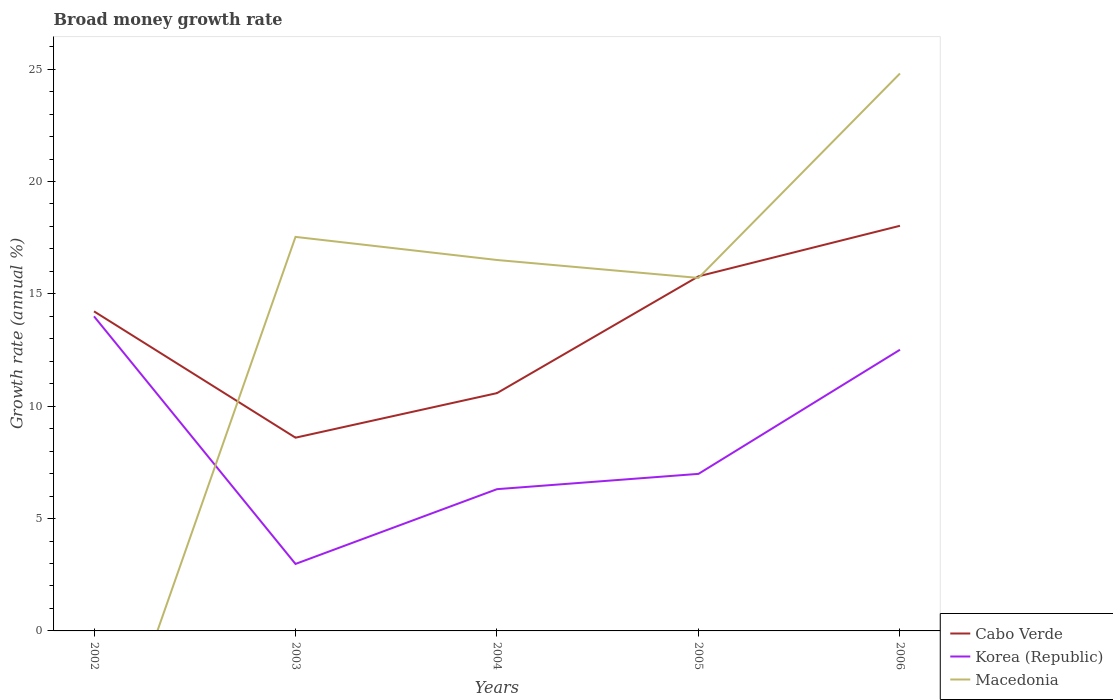How many different coloured lines are there?
Offer a terse response. 3. Does the line corresponding to Korea (Republic) intersect with the line corresponding to Macedonia?
Keep it short and to the point. Yes. What is the total growth rate in Cabo Verde in the graph?
Ensure brevity in your answer.  -2.25. What is the difference between the highest and the second highest growth rate in Cabo Verde?
Ensure brevity in your answer.  9.43. How many lines are there?
Provide a short and direct response. 3. How many years are there in the graph?
Offer a terse response. 5. What is the difference between two consecutive major ticks on the Y-axis?
Provide a succinct answer. 5. Does the graph contain any zero values?
Offer a terse response. Yes. Does the graph contain grids?
Ensure brevity in your answer.  No. Where does the legend appear in the graph?
Make the answer very short. Bottom right. What is the title of the graph?
Provide a short and direct response. Broad money growth rate. Does "Syrian Arab Republic" appear as one of the legend labels in the graph?
Give a very brief answer. No. What is the label or title of the X-axis?
Give a very brief answer. Years. What is the label or title of the Y-axis?
Keep it short and to the point. Growth rate (annual %). What is the Growth rate (annual %) of Cabo Verde in 2002?
Your response must be concise. 14.22. What is the Growth rate (annual %) in Korea (Republic) in 2002?
Give a very brief answer. 14. What is the Growth rate (annual %) in Macedonia in 2002?
Make the answer very short. 0. What is the Growth rate (annual %) in Cabo Verde in 2003?
Your response must be concise. 8.6. What is the Growth rate (annual %) of Korea (Republic) in 2003?
Keep it short and to the point. 2.98. What is the Growth rate (annual %) of Macedonia in 2003?
Your answer should be compact. 17.53. What is the Growth rate (annual %) of Cabo Verde in 2004?
Your response must be concise. 10.58. What is the Growth rate (annual %) in Korea (Republic) in 2004?
Offer a terse response. 6.31. What is the Growth rate (annual %) in Macedonia in 2004?
Ensure brevity in your answer.  16.51. What is the Growth rate (annual %) of Cabo Verde in 2005?
Offer a very short reply. 15.78. What is the Growth rate (annual %) of Korea (Republic) in 2005?
Offer a terse response. 6.99. What is the Growth rate (annual %) in Macedonia in 2005?
Keep it short and to the point. 15.71. What is the Growth rate (annual %) of Cabo Verde in 2006?
Offer a terse response. 18.03. What is the Growth rate (annual %) of Korea (Republic) in 2006?
Provide a succinct answer. 12.51. What is the Growth rate (annual %) of Macedonia in 2006?
Keep it short and to the point. 24.81. Across all years, what is the maximum Growth rate (annual %) in Cabo Verde?
Keep it short and to the point. 18.03. Across all years, what is the maximum Growth rate (annual %) of Korea (Republic)?
Provide a short and direct response. 14. Across all years, what is the maximum Growth rate (annual %) of Macedonia?
Make the answer very short. 24.81. Across all years, what is the minimum Growth rate (annual %) in Cabo Verde?
Provide a short and direct response. 8.6. Across all years, what is the minimum Growth rate (annual %) in Korea (Republic)?
Your answer should be very brief. 2.98. What is the total Growth rate (annual %) of Cabo Verde in the graph?
Give a very brief answer. 67.21. What is the total Growth rate (annual %) of Korea (Republic) in the graph?
Your response must be concise. 42.79. What is the total Growth rate (annual %) of Macedonia in the graph?
Your response must be concise. 74.56. What is the difference between the Growth rate (annual %) of Cabo Verde in 2002 and that in 2003?
Your answer should be very brief. 5.62. What is the difference between the Growth rate (annual %) in Korea (Republic) in 2002 and that in 2003?
Ensure brevity in your answer.  11.02. What is the difference between the Growth rate (annual %) in Cabo Verde in 2002 and that in 2004?
Provide a succinct answer. 3.64. What is the difference between the Growth rate (annual %) in Korea (Republic) in 2002 and that in 2004?
Offer a very short reply. 7.69. What is the difference between the Growth rate (annual %) of Cabo Verde in 2002 and that in 2005?
Give a very brief answer. -1.56. What is the difference between the Growth rate (annual %) in Korea (Republic) in 2002 and that in 2005?
Your answer should be compact. 7.01. What is the difference between the Growth rate (annual %) in Cabo Verde in 2002 and that in 2006?
Make the answer very short. -3.81. What is the difference between the Growth rate (annual %) in Korea (Republic) in 2002 and that in 2006?
Provide a succinct answer. 1.49. What is the difference between the Growth rate (annual %) in Cabo Verde in 2003 and that in 2004?
Keep it short and to the point. -1.98. What is the difference between the Growth rate (annual %) of Korea (Republic) in 2003 and that in 2004?
Ensure brevity in your answer.  -3.33. What is the difference between the Growth rate (annual %) of Macedonia in 2003 and that in 2004?
Give a very brief answer. 1.03. What is the difference between the Growth rate (annual %) in Cabo Verde in 2003 and that in 2005?
Provide a short and direct response. -7.18. What is the difference between the Growth rate (annual %) of Korea (Republic) in 2003 and that in 2005?
Give a very brief answer. -4.01. What is the difference between the Growth rate (annual %) in Macedonia in 2003 and that in 2005?
Keep it short and to the point. 1.83. What is the difference between the Growth rate (annual %) in Cabo Verde in 2003 and that in 2006?
Ensure brevity in your answer.  -9.43. What is the difference between the Growth rate (annual %) in Korea (Republic) in 2003 and that in 2006?
Offer a terse response. -9.53. What is the difference between the Growth rate (annual %) of Macedonia in 2003 and that in 2006?
Your response must be concise. -7.27. What is the difference between the Growth rate (annual %) in Cabo Verde in 2004 and that in 2005?
Offer a terse response. -5.2. What is the difference between the Growth rate (annual %) in Korea (Republic) in 2004 and that in 2005?
Provide a short and direct response. -0.68. What is the difference between the Growth rate (annual %) of Macedonia in 2004 and that in 2005?
Keep it short and to the point. 0.8. What is the difference between the Growth rate (annual %) of Cabo Verde in 2004 and that in 2006?
Provide a short and direct response. -7.45. What is the difference between the Growth rate (annual %) in Korea (Republic) in 2004 and that in 2006?
Give a very brief answer. -6.2. What is the difference between the Growth rate (annual %) in Macedonia in 2004 and that in 2006?
Offer a terse response. -8.3. What is the difference between the Growth rate (annual %) in Cabo Verde in 2005 and that in 2006?
Provide a short and direct response. -2.25. What is the difference between the Growth rate (annual %) in Korea (Republic) in 2005 and that in 2006?
Keep it short and to the point. -5.52. What is the difference between the Growth rate (annual %) in Macedonia in 2005 and that in 2006?
Your answer should be compact. -9.1. What is the difference between the Growth rate (annual %) in Cabo Verde in 2002 and the Growth rate (annual %) in Korea (Republic) in 2003?
Your answer should be very brief. 11.24. What is the difference between the Growth rate (annual %) of Cabo Verde in 2002 and the Growth rate (annual %) of Macedonia in 2003?
Ensure brevity in your answer.  -3.31. What is the difference between the Growth rate (annual %) in Korea (Republic) in 2002 and the Growth rate (annual %) in Macedonia in 2003?
Provide a short and direct response. -3.53. What is the difference between the Growth rate (annual %) in Cabo Verde in 2002 and the Growth rate (annual %) in Korea (Republic) in 2004?
Your answer should be very brief. 7.91. What is the difference between the Growth rate (annual %) of Cabo Verde in 2002 and the Growth rate (annual %) of Macedonia in 2004?
Provide a succinct answer. -2.29. What is the difference between the Growth rate (annual %) of Korea (Republic) in 2002 and the Growth rate (annual %) of Macedonia in 2004?
Offer a terse response. -2.51. What is the difference between the Growth rate (annual %) in Cabo Verde in 2002 and the Growth rate (annual %) in Korea (Republic) in 2005?
Your response must be concise. 7.23. What is the difference between the Growth rate (annual %) in Cabo Verde in 2002 and the Growth rate (annual %) in Macedonia in 2005?
Ensure brevity in your answer.  -1.49. What is the difference between the Growth rate (annual %) of Korea (Republic) in 2002 and the Growth rate (annual %) of Macedonia in 2005?
Offer a very short reply. -1.71. What is the difference between the Growth rate (annual %) in Cabo Verde in 2002 and the Growth rate (annual %) in Korea (Republic) in 2006?
Ensure brevity in your answer.  1.71. What is the difference between the Growth rate (annual %) in Cabo Verde in 2002 and the Growth rate (annual %) in Macedonia in 2006?
Offer a very short reply. -10.59. What is the difference between the Growth rate (annual %) in Korea (Republic) in 2002 and the Growth rate (annual %) in Macedonia in 2006?
Keep it short and to the point. -10.81. What is the difference between the Growth rate (annual %) in Cabo Verde in 2003 and the Growth rate (annual %) in Korea (Republic) in 2004?
Your answer should be compact. 2.29. What is the difference between the Growth rate (annual %) of Cabo Verde in 2003 and the Growth rate (annual %) of Macedonia in 2004?
Offer a very short reply. -7.91. What is the difference between the Growth rate (annual %) of Korea (Republic) in 2003 and the Growth rate (annual %) of Macedonia in 2004?
Your answer should be compact. -13.53. What is the difference between the Growth rate (annual %) of Cabo Verde in 2003 and the Growth rate (annual %) of Korea (Republic) in 2005?
Provide a short and direct response. 1.61. What is the difference between the Growth rate (annual %) of Cabo Verde in 2003 and the Growth rate (annual %) of Macedonia in 2005?
Provide a succinct answer. -7.11. What is the difference between the Growth rate (annual %) in Korea (Republic) in 2003 and the Growth rate (annual %) in Macedonia in 2005?
Provide a short and direct response. -12.73. What is the difference between the Growth rate (annual %) in Cabo Verde in 2003 and the Growth rate (annual %) in Korea (Republic) in 2006?
Your answer should be very brief. -3.91. What is the difference between the Growth rate (annual %) of Cabo Verde in 2003 and the Growth rate (annual %) of Macedonia in 2006?
Make the answer very short. -16.21. What is the difference between the Growth rate (annual %) of Korea (Republic) in 2003 and the Growth rate (annual %) of Macedonia in 2006?
Provide a succinct answer. -21.83. What is the difference between the Growth rate (annual %) in Cabo Verde in 2004 and the Growth rate (annual %) in Korea (Republic) in 2005?
Your answer should be compact. 3.59. What is the difference between the Growth rate (annual %) in Cabo Verde in 2004 and the Growth rate (annual %) in Macedonia in 2005?
Keep it short and to the point. -5.13. What is the difference between the Growth rate (annual %) in Korea (Republic) in 2004 and the Growth rate (annual %) in Macedonia in 2005?
Give a very brief answer. -9.4. What is the difference between the Growth rate (annual %) of Cabo Verde in 2004 and the Growth rate (annual %) of Korea (Republic) in 2006?
Give a very brief answer. -1.93. What is the difference between the Growth rate (annual %) in Cabo Verde in 2004 and the Growth rate (annual %) in Macedonia in 2006?
Offer a terse response. -14.22. What is the difference between the Growth rate (annual %) in Korea (Republic) in 2004 and the Growth rate (annual %) in Macedonia in 2006?
Offer a very short reply. -18.5. What is the difference between the Growth rate (annual %) of Cabo Verde in 2005 and the Growth rate (annual %) of Korea (Republic) in 2006?
Keep it short and to the point. 3.27. What is the difference between the Growth rate (annual %) of Cabo Verde in 2005 and the Growth rate (annual %) of Macedonia in 2006?
Ensure brevity in your answer.  -9.03. What is the difference between the Growth rate (annual %) in Korea (Republic) in 2005 and the Growth rate (annual %) in Macedonia in 2006?
Offer a very short reply. -17.82. What is the average Growth rate (annual %) in Cabo Verde per year?
Make the answer very short. 13.44. What is the average Growth rate (annual %) in Korea (Republic) per year?
Provide a succinct answer. 8.56. What is the average Growth rate (annual %) in Macedonia per year?
Provide a succinct answer. 14.91. In the year 2002, what is the difference between the Growth rate (annual %) of Cabo Verde and Growth rate (annual %) of Korea (Republic)?
Your response must be concise. 0.22. In the year 2003, what is the difference between the Growth rate (annual %) of Cabo Verde and Growth rate (annual %) of Korea (Republic)?
Provide a succinct answer. 5.62. In the year 2003, what is the difference between the Growth rate (annual %) of Cabo Verde and Growth rate (annual %) of Macedonia?
Offer a terse response. -8.93. In the year 2003, what is the difference between the Growth rate (annual %) in Korea (Republic) and Growth rate (annual %) in Macedonia?
Offer a very short reply. -14.55. In the year 2004, what is the difference between the Growth rate (annual %) of Cabo Verde and Growth rate (annual %) of Korea (Republic)?
Offer a very short reply. 4.27. In the year 2004, what is the difference between the Growth rate (annual %) of Cabo Verde and Growth rate (annual %) of Macedonia?
Ensure brevity in your answer.  -5.92. In the year 2004, what is the difference between the Growth rate (annual %) of Korea (Republic) and Growth rate (annual %) of Macedonia?
Offer a terse response. -10.2. In the year 2005, what is the difference between the Growth rate (annual %) in Cabo Verde and Growth rate (annual %) in Korea (Republic)?
Provide a short and direct response. 8.79. In the year 2005, what is the difference between the Growth rate (annual %) in Cabo Verde and Growth rate (annual %) in Macedonia?
Keep it short and to the point. 0.07. In the year 2005, what is the difference between the Growth rate (annual %) in Korea (Republic) and Growth rate (annual %) in Macedonia?
Your response must be concise. -8.72. In the year 2006, what is the difference between the Growth rate (annual %) in Cabo Verde and Growth rate (annual %) in Korea (Republic)?
Offer a very short reply. 5.52. In the year 2006, what is the difference between the Growth rate (annual %) of Cabo Verde and Growth rate (annual %) of Macedonia?
Provide a short and direct response. -6.78. In the year 2006, what is the difference between the Growth rate (annual %) in Korea (Republic) and Growth rate (annual %) in Macedonia?
Provide a succinct answer. -12.29. What is the ratio of the Growth rate (annual %) of Cabo Verde in 2002 to that in 2003?
Offer a very short reply. 1.65. What is the ratio of the Growth rate (annual %) of Korea (Republic) in 2002 to that in 2003?
Provide a short and direct response. 4.7. What is the ratio of the Growth rate (annual %) of Cabo Verde in 2002 to that in 2004?
Provide a succinct answer. 1.34. What is the ratio of the Growth rate (annual %) of Korea (Republic) in 2002 to that in 2004?
Provide a succinct answer. 2.22. What is the ratio of the Growth rate (annual %) in Cabo Verde in 2002 to that in 2005?
Offer a very short reply. 0.9. What is the ratio of the Growth rate (annual %) in Korea (Republic) in 2002 to that in 2005?
Provide a short and direct response. 2. What is the ratio of the Growth rate (annual %) of Cabo Verde in 2002 to that in 2006?
Offer a very short reply. 0.79. What is the ratio of the Growth rate (annual %) in Korea (Republic) in 2002 to that in 2006?
Offer a very short reply. 1.12. What is the ratio of the Growth rate (annual %) of Cabo Verde in 2003 to that in 2004?
Your response must be concise. 0.81. What is the ratio of the Growth rate (annual %) of Korea (Republic) in 2003 to that in 2004?
Give a very brief answer. 0.47. What is the ratio of the Growth rate (annual %) of Macedonia in 2003 to that in 2004?
Provide a short and direct response. 1.06. What is the ratio of the Growth rate (annual %) of Cabo Verde in 2003 to that in 2005?
Provide a short and direct response. 0.55. What is the ratio of the Growth rate (annual %) in Korea (Republic) in 2003 to that in 2005?
Your answer should be very brief. 0.43. What is the ratio of the Growth rate (annual %) in Macedonia in 2003 to that in 2005?
Offer a very short reply. 1.12. What is the ratio of the Growth rate (annual %) of Cabo Verde in 2003 to that in 2006?
Give a very brief answer. 0.48. What is the ratio of the Growth rate (annual %) of Korea (Republic) in 2003 to that in 2006?
Keep it short and to the point. 0.24. What is the ratio of the Growth rate (annual %) in Macedonia in 2003 to that in 2006?
Provide a short and direct response. 0.71. What is the ratio of the Growth rate (annual %) of Cabo Verde in 2004 to that in 2005?
Ensure brevity in your answer.  0.67. What is the ratio of the Growth rate (annual %) of Korea (Republic) in 2004 to that in 2005?
Keep it short and to the point. 0.9. What is the ratio of the Growth rate (annual %) of Macedonia in 2004 to that in 2005?
Offer a very short reply. 1.05. What is the ratio of the Growth rate (annual %) in Cabo Verde in 2004 to that in 2006?
Your answer should be compact. 0.59. What is the ratio of the Growth rate (annual %) in Korea (Republic) in 2004 to that in 2006?
Provide a succinct answer. 0.5. What is the ratio of the Growth rate (annual %) of Macedonia in 2004 to that in 2006?
Your response must be concise. 0.67. What is the ratio of the Growth rate (annual %) in Cabo Verde in 2005 to that in 2006?
Your response must be concise. 0.88. What is the ratio of the Growth rate (annual %) in Korea (Republic) in 2005 to that in 2006?
Ensure brevity in your answer.  0.56. What is the ratio of the Growth rate (annual %) of Macedonia in 2005 to that in 2006?
Provide a succinct answer. 0.63. What is the difference between the highest and the second highest Growth rate (annual %) of Cabo Verde?
Your response must be concise. 2.25. What is the difference between the highest and the second highest Growth rate (annual %) in Korea (Republic)?
Make the answer very short. 1.49. What is the difference between the highest and the second highest Growth rate (annual %) of Macedonia?
Keep it short and to the point. 7.27. What is the difference between the highest and the lowest Growth rate (annual %) of Cabo Verde?
Ensure brevity in your answer.  9.43. What is the difference between the highest and the lowest Growth rate (annual %) in Korea (Republic)?
Provide a short and direct response. 11.02. What is the difference between the highest and the lowest Growth rate (annual %) of Macedonia?
Offer a terse response. 24.81. 